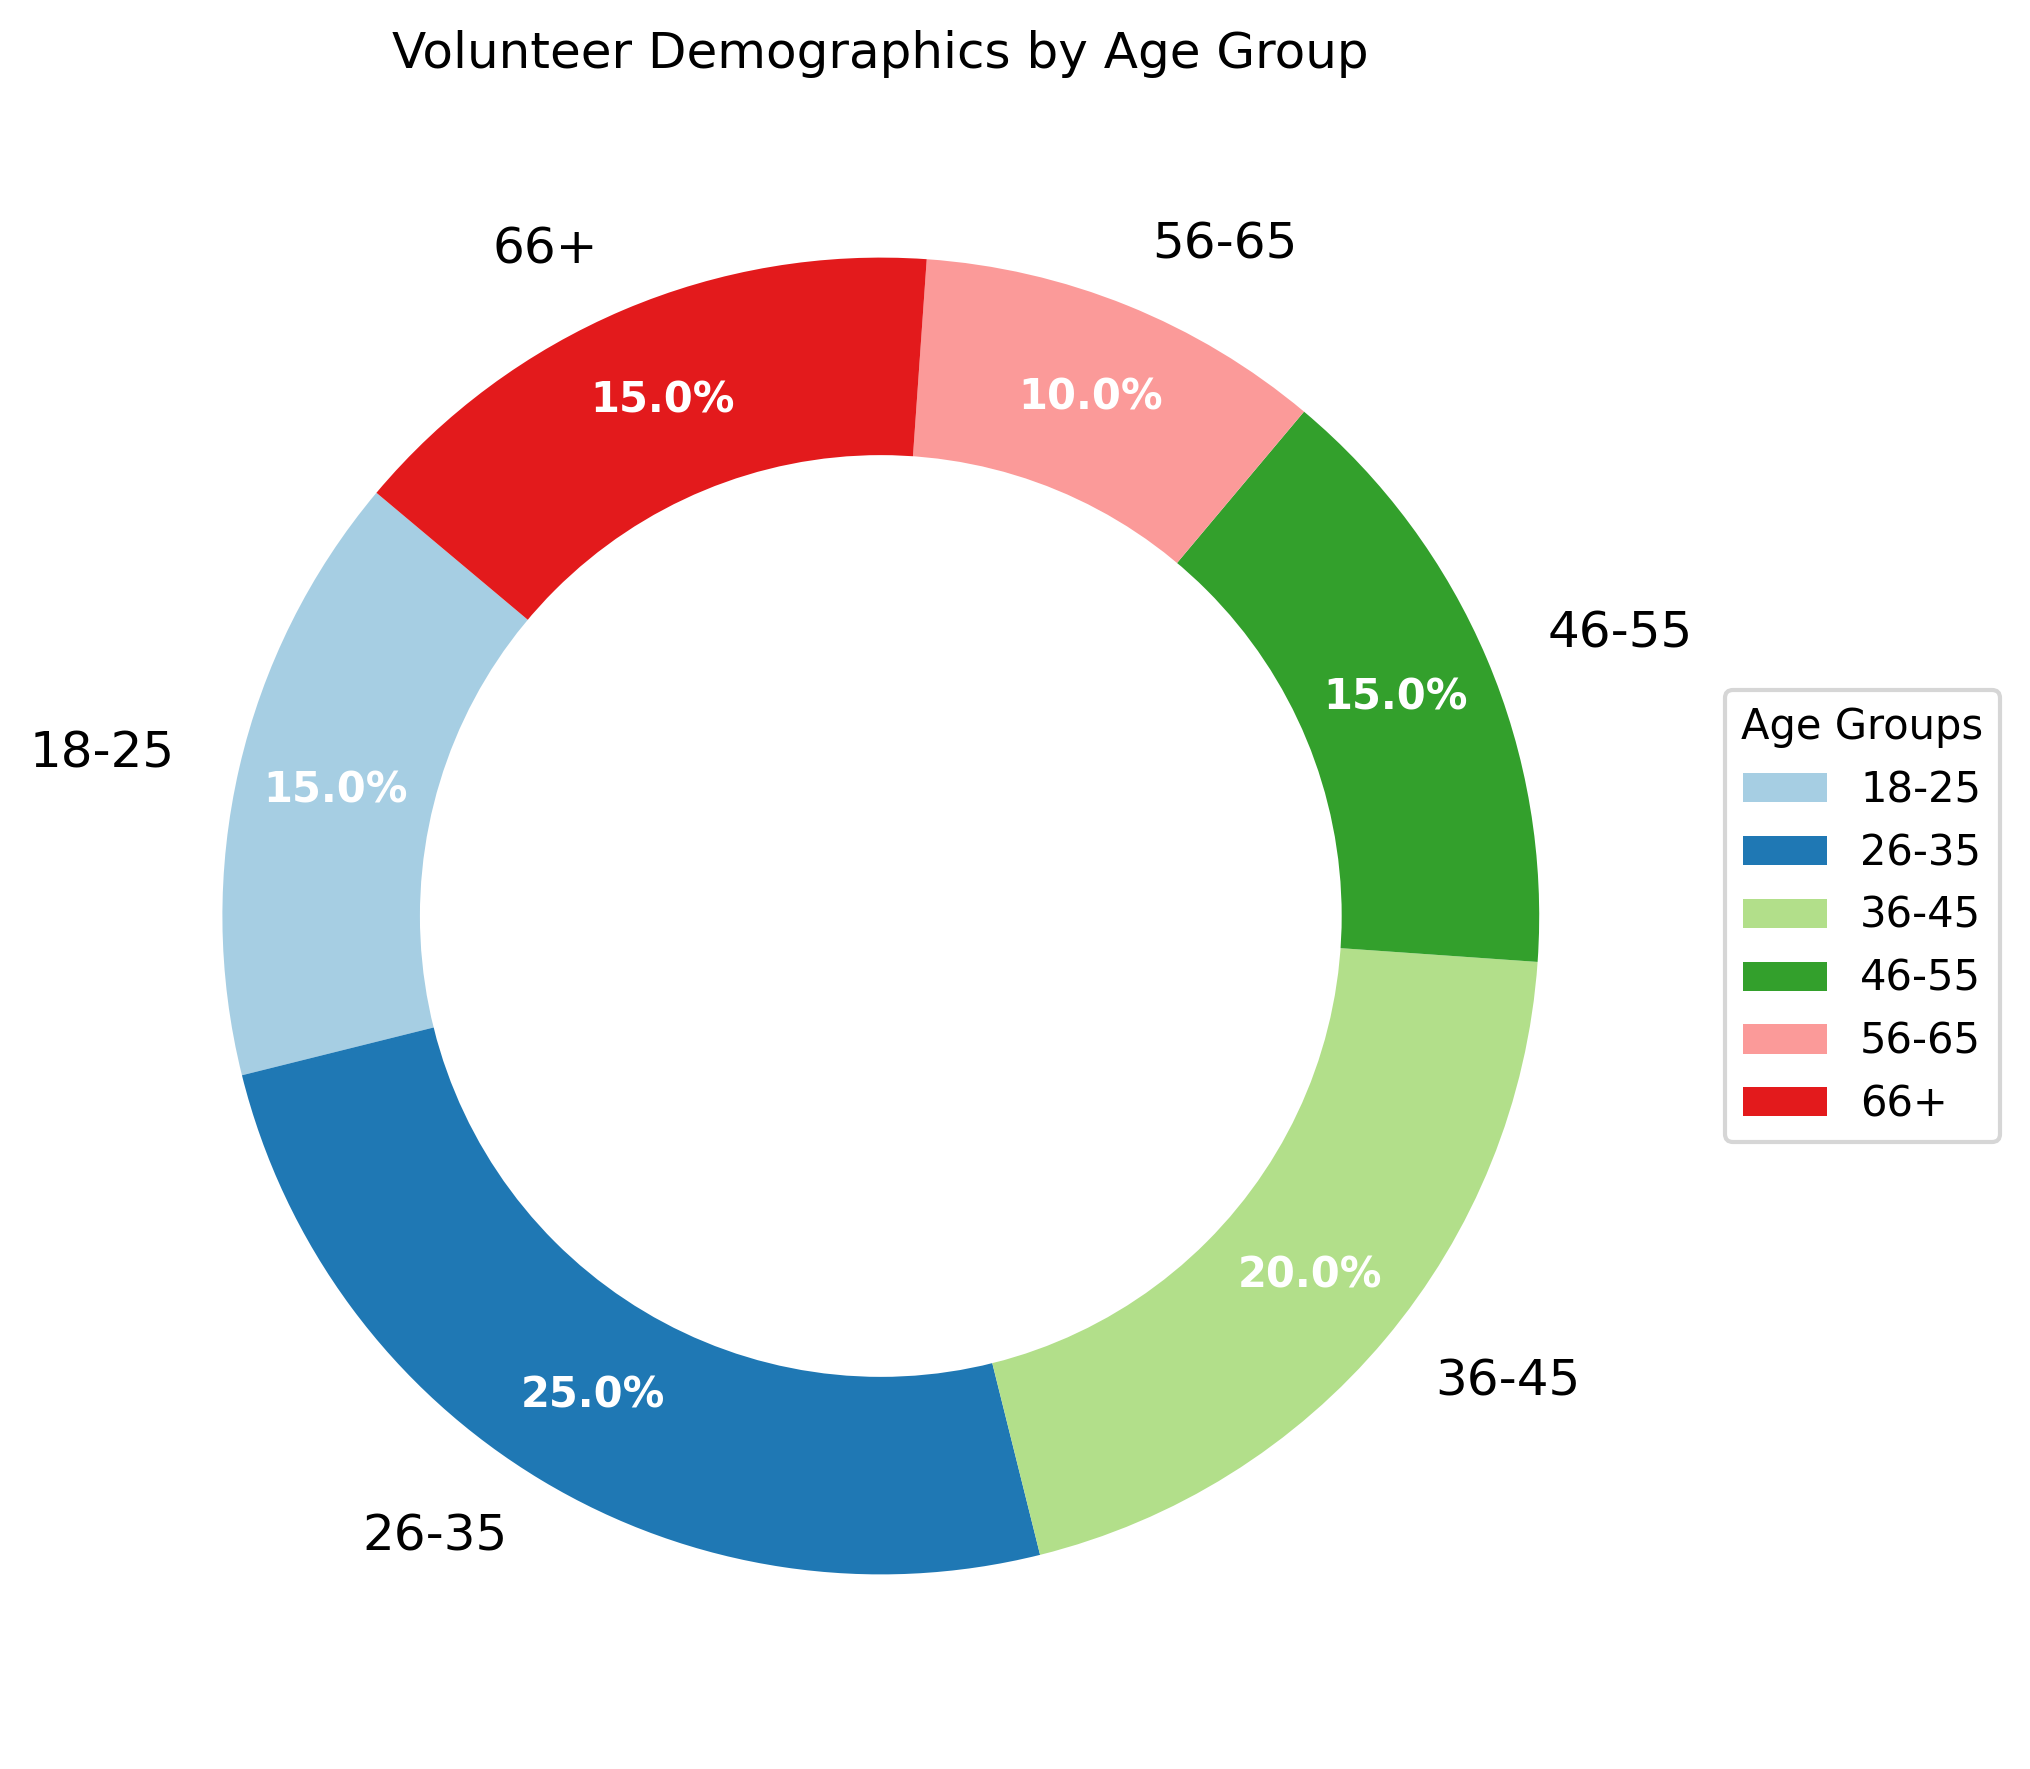What's the largest age group of volunteers? The age group with the highest percentage is the largest. By looking at the pie chart, the 26-35 age group has the highest percentage, which is 25%.
Answer: 26-35 Which two age groups have the same percentage of volunteers? By observing the pie chart, the 18-25 and 46-55 age groups both have 15%, and the 66+ age group also has 15%. We can mention any of these pairs.
Answer: 18-25 and 66+ What is the percentage difference between the 26-35 age group and the 56-65 age group? The percentage for the 26-35 age group is 25%, and for the 56-65 age group, it is 10%. The difference is calculated as 25% - 10% = 15%.
Answer: 15% How many age groups have at least 15% of the volunteers? Looking at the pie chart, the age groups with at least 15% are 18-25 (15%), 26-35 (25%), 36-45 (20%), 46-55 (15%), and 66+ (15%). Counting these, we get five age groups.
Answer: 5 Which age group has a lower percentage than 36-45 but higher than 18-25? The pie chart shows the 36-45 age group at 20%. The age groups between these percentages are 46-55 (15%) and 66+ (15%). Since each of these fits between 20% and 15%, we can list any of them.
Answer: 46-55 What is the total percentage of volunteers in the age groups above 45? To find the total percentage of age groups above 45, we add the percentages for the 46-55, 56-65, and 66+ age groups: 15% + 10% + 15% = 40%.
Answer: 40% Is the percentage of volunteers in the 26-35 age group greater than the combined percentage of the 56-65 and 66+ age groups? The percentage for the 26-35 age group is 25%. For the 56-65 and 66+ groups combined, it is 10% + 15% = 25%. Since 25% is equal to 25%, the 26-35 age group does not have a greater percentage; they are equal.
Answer: No, they are equal Between the age groups 18-25 and 46-55, which group visually appears larger in the pie chart? By examining the sizes of the pie slices for these two age groups, the age groups 18-25 and 46-55 both have 15% each. They appear equally sized on the chart.
Answer: Both are equal 